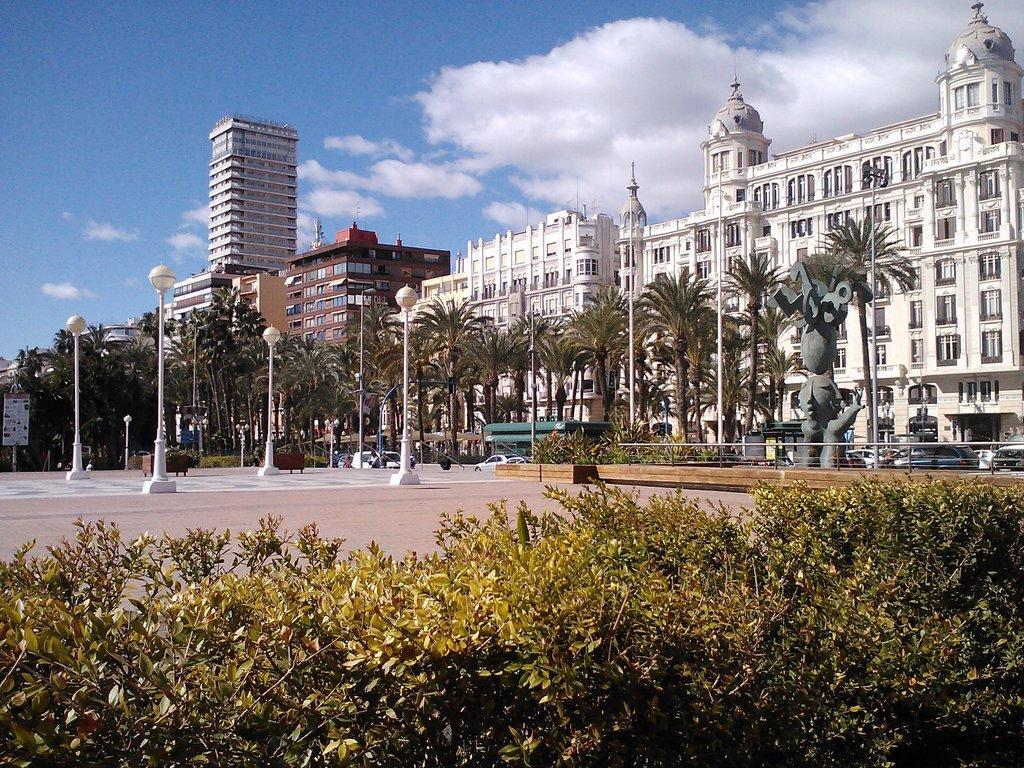How would you summarize this image in a sentence or two? In this image, we can see trees, poles, lights, board, plants, walkway and few objects. Background we can see vehicles, buildings, walls, windows and cloudy sky. 